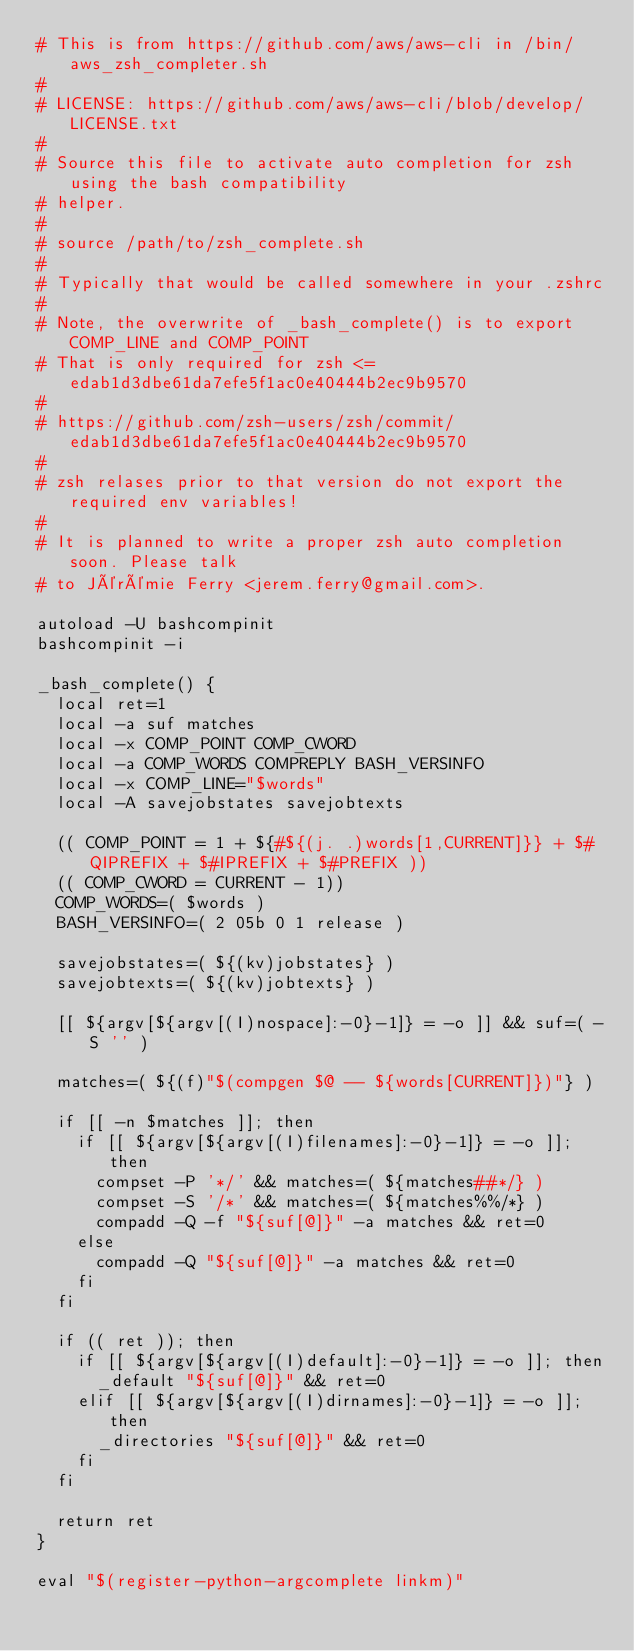<code> <loc_0><loc_0><loc_500><loc_500><_Bash_># This is from https://github.com/aws/aws-cli in /bin/aws_zsh_completer.sh
#
# LICENSE: https://github.com/aws/aws-cli/blob/develop/LICENSE.txt
#
# Source this file to activate auto completion for zsh using the bash compatibility
# helper.
#
# source /path/to/zsh_complete.sh
#
# Typically that would be called somewhere in your .zshrc
#
# Note, the overwrite of _bash_complete() is to export COMP_LINE and COMP_POINT
# That is only required for zsh <= edab1d3dbe61da7efe5f1ac0e40444b2ec9b9570
#
# https://github.com/zsh-users/zsh/commit/edab1d3dbe61da7efe5f1ac0e40444b2ec9b9570
#
# zsh relases prior to that version do not export the required env variables!
#
# It is planned to write a proper zsh auto completion soon. Please talk
# to Jérémie Ferry <jerem.ferry@gmail.com>.

autoload -U bashcompinit
bashcompinit -i

_bash_complete() {
  local ret=1
  local -a suf matches
  local -x COMP_POINT COMP_CWORD
  local -a COMP_WORDS COMPREPLY BASH_VERSINFO
  local -x COMP_LINE="$words"
  local -A savejobstates savejobtexts

  (( COMP_POINT = 1 + ${#${(j. .)words[1,CURRENT]}} + $#QIPREFIX + $#IPREFIX + $#PREFIX ))
  (( COMP_CWORD = CURRENT - 1))
  COMP_WORDS=( $words )
  BASH_VERSINFO=( 2 05b 0 1 release )

  savejobstates=( ${(kv)jobstates} )
  savejobtexts=( ${(kv)jobtexts} )

  [[ ${argv[${argv[(I)nospace]:-0}-1]} = -o ]] && suf=( -S '' )

  matches=( ${(f)"$(compgen $@ -- ${words[CURRENT]})"} )

  if [[ -n $matches ]]; then
    if [[ ${argv[${argv[(I)filenames]:-0}-1]} = -o ]]; then
      compset -P '*/' && matches=( ${matches##*/} )
      compset -S '/*' && matches=( ${matches%%/*} )
      compadd -Q -f "${suf[@]}" -a matches && ret=0
    else
      compadd -Q "${suf[@]}" -a matches && ret=0
    fi
  fi

  if (( ret )); then
    if [[ ${argv[${argv[(I)default]:-0}-1]} = -o ]]; then
      _default "${suf[@]}" && ret=0
    elif [[ ${argv[${argv[(I)dirnames]:-0}-1]} = -o ]]; then
      _directories "${suf[@]}" && ret=0
    fi
  fi

  return ret
}

eval "$(register-python-argcomplete linkm)"
</code> 